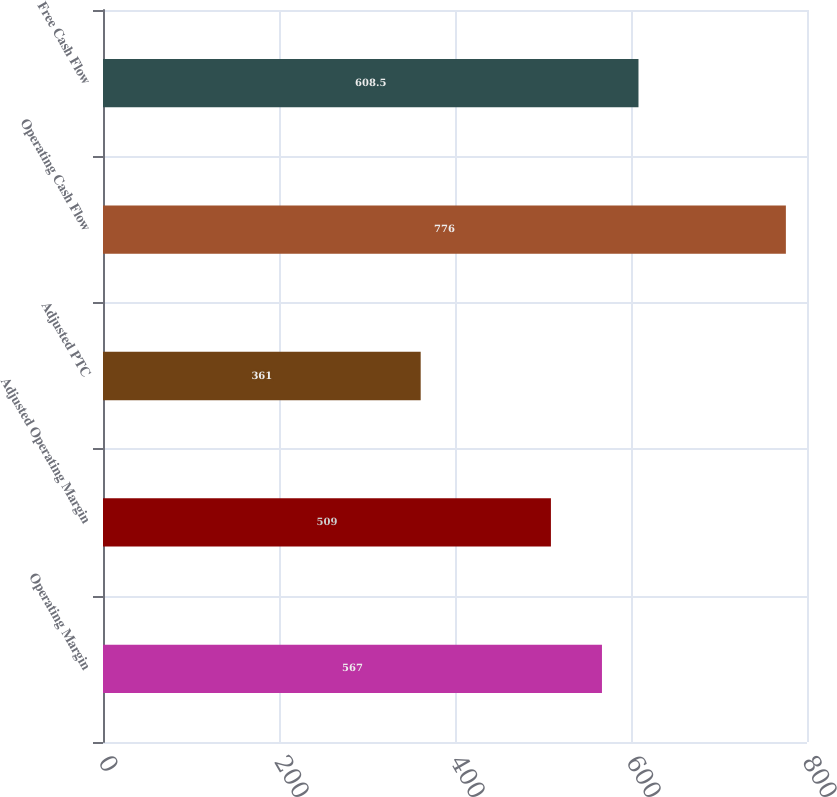Convert chart to OTSL. <chart><loc_0><loc_0><loc_500><loc_500><bar_chart><fcel>Operating Margin<fcel>Adjusted Operating Margin<fcel>Adjusted PTC<fcel>Operating Cash Flow<fcel>Free Cash Flow<nl><fcel>567<fcel>509<fcel>361<fcel>776<fcel>608.5<nl></chart> 